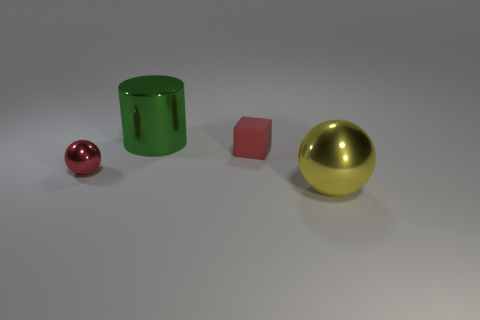Add 3 small red matte things. How many objects exist? 7 Subtract all cylinders. How many objects are left? 3 Add 1 big yellow matte cylinders. How many big yellow matte cylinders exist? 1 Subtract 1 yellow spheres. How many objects are left? 3 Subtract all small brown metallic cylinders. Subtract all shiny objects. How many objects are left? 1 Add 1 big cylinders. How many big cylinders are left? 2 